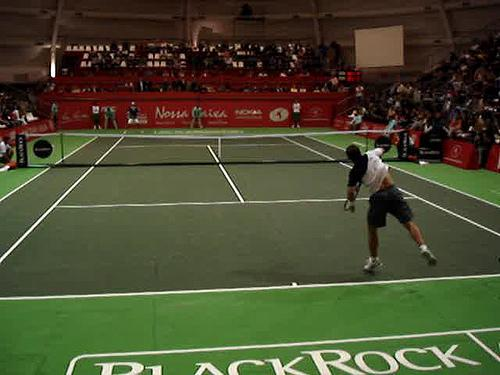What type of tennis swing is the main on the bottom of the court in the middle of?

Choices:
A) serve
B) backhand
C) drop shot
D) forearm serve 